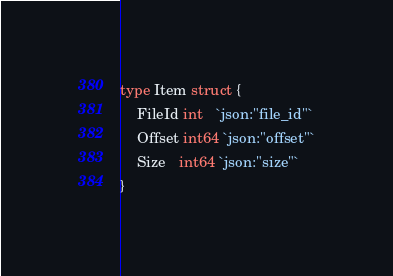Convert code to text. <code><loc_0><loc_0><loc_500><loc_500><_Go_>
type Item struct {
	FileId int   `json:"file_id"`
	Offset int64 `json:"offset"`
	Size   int64 `json:"size"`
}
</code> 